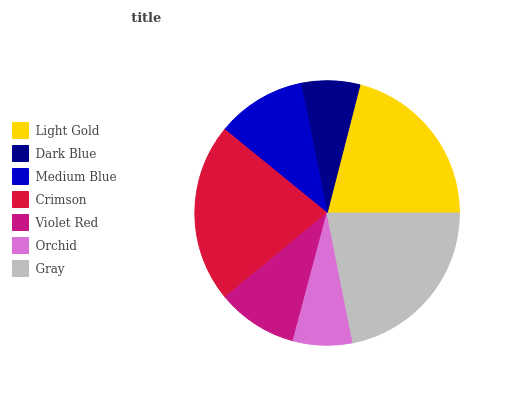Is Dark Blue the minimum?
Answer yes or no. Yes. Is Gray the maximum?
Answer yes or no. Yes. Is Medium Blue the minimum?
Answer yes or no. No. Is Medium Blue the maximum?
Answer yes or no. No. Is Medium Blue greater than Dark Blue?
Answer yes or no. Yes. Is Dark Blue less than Medium Blue?
Answer yes or no. Yes. Is Dark Blue greater than Medium Blue?
Answer yes or no. No. Is Medium Blue less than Dark Blue?
Answer yes or no. No. Is Medium Blue the high median?
Answer yes or no. Yes. Is Medium Blue the low median?
Answer yes or no. Yes. Is Orchid the high median?
Answer yes or no. No. Is Gray the low median?
Answer yes or no. No. 